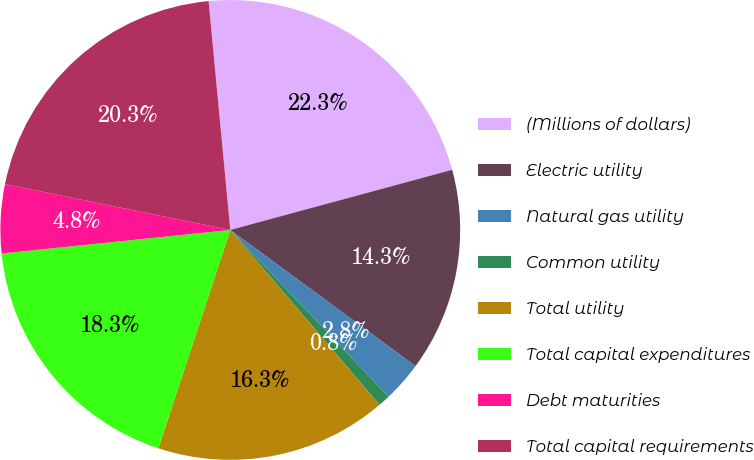<chart> <loc_0><loc_0><loc_500><loc_500><pie_chart><fcel>(Millions of dollars)<fcel>Electric utility<fcel>Natural gas utility<fcel>Common utility<fcel>Total utility<fcel>Total capital expenditures<fcel>Debt maturities<fcel>Total capital requirements<nl><fcel>22.29%<fcel>14.3%<fcel>2.83%<fcel>0.84%<fcel>16.31%<fcel>18.3%<fcel>4.83%<fcel>20.3%<nl></chart> 